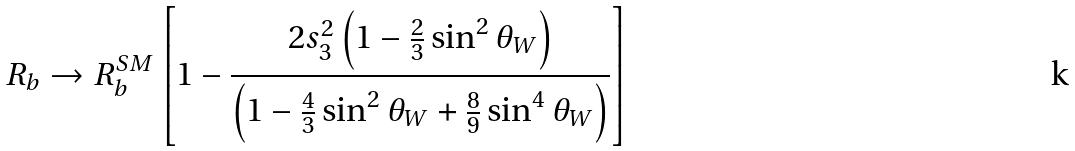<formula> <loc_0><loc_0><loc_500><loc_500>R _ { b } \rightarrow R _ { b } ^ { S M } \left [ 1 - \frac { 2 s ^ { 2 } _ { 3 } \left ( 1 - \frac { 2 } { 3 } \sin ^ { 2 } \theta _ { W } \right ) } { \left ( 1 - \frac { 4 } { 3 } \sin ^ { 2 } \theta _ { W } + \frac { 8 } { 9 } \sin ^ { 4 } \theta _ { W } \right ) } \right ]</formula> 